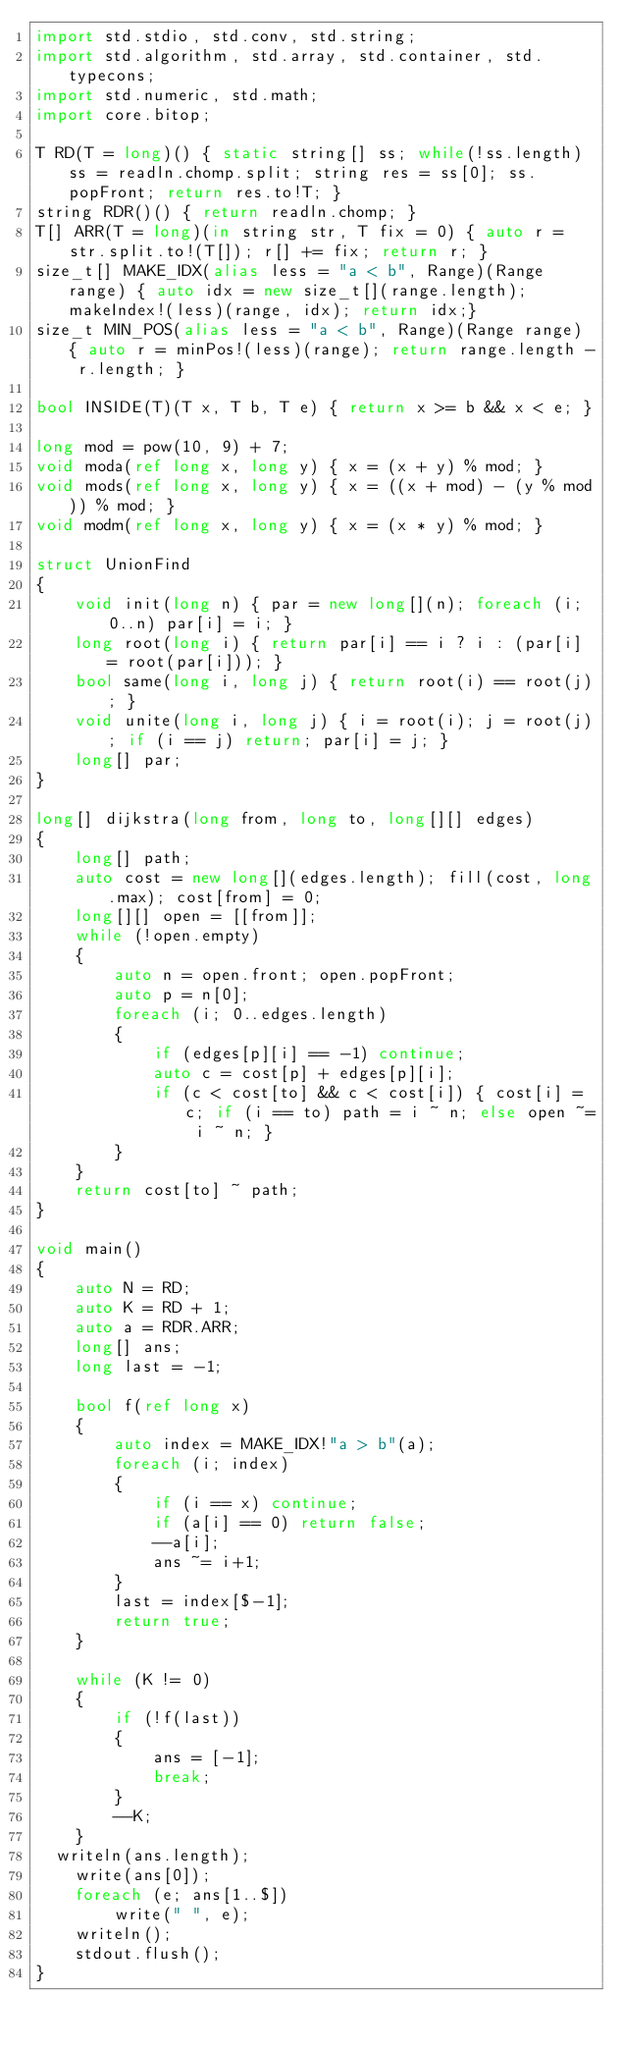<code> <loc_0><loc_0><loc_500><loc_500><_D_>import std.stdio, std.conv, std.string;
import std.algorithm, std.array, std.container, std.typecons;
import std.numeric, std.math;
import core.bitop;
 
T RD(T = long)() { static string[] ss; while(!ss.length) ss = readln.chomp.split; string res = ss[0]; ss.popFront; return res.to!T; }
string RDR()() { return readln.chomp; }
T[] ARR(T = long)(in string str, T fix = 0) { auto r = str.split.to!(T[]); r[] += fix; return r; }
size_t[] MAKE_IDX(alias less = "a < b", Range)(Range range) { auto idx = new size_t[](range.length); makeIndex!(less)(range, idx); return idx;}
size_t MIN_POS(alias less = "a < b", Range)(Range range) { auto r = minPos!(less)(range); return range.length - r.length; }
 
bool INSIDE(T)(T x, T b, T e) { return x >= b && x < e; }
 
long mod = pow(10, 9) + 7;
void moda(ref long x, long y) { x = (x + y) % mod; }
void mods(ref long x, long y) { x = ((x + mod) - (y % mod)) % mod; }
void modm(ref long x, long y) { x = (x * y) % mod; }
 
struct UnionFind
{
	void init(long n) { par = new long[](n); foreach (i; 0..n) par[i] = i; }
	long root(long i) { return par[i] == i ? i : (par[i] = root(par[i])); }
	bool same(long i, long j) { return root(i) == root(j); }
	void unite(long i, long j) { i = root(i); j = root(j); if (i == j) return; par[i] = j; }
	long[] par;
}
 
long[] dijkstra(long from, long to, long[][] edges)
{
	long[] path;
	auto cost = new long[](edges.length); fill(cost, long.max); cost[from] = 0;
	long[][] open = [[from]];
	while (!open.empty)
	{
		auto n = open.front; open.popFront;
		auto p = n[0];
		foreach (i; 0..edges.length)
		{
			if (edges[p][i] == -1) continue;
			auto c = cost[p] + edges[p][i];
			if (c < cost[to] && c < cost[i]) { cost[i] = c; if (i == to) path = i ~ n; else open ~= i ~ n; }
		}
	}
	return cost[to] ~ path;
}
 
void main()
{
	auto N = RD;
	auto K = RD + 1;
	auto a = RDR.ARR;
	long[] ans;
	long last = -1;
 
	bool f(ref long x)
	{
		auto index = MAKE_IDX!"a > b"(a);
		foreach (i; index)
		{
			if (i == x) continue;
			if (a[i] == 0) return false;
			--a[i];
			ans ~= i+1;
		}
		last = index[$-1];
		return true;
	}
 
	while (K != 0)
	{
		if (!f(last))
		{
			ans = [-1];
			break;
		}
		--K;
	}
  writeln(ans.length);
	write(ans[0]);
	foreach (e; ans[1..$])
		write(" ", e);
	writeln();
	stdout.flush();
}</code> 